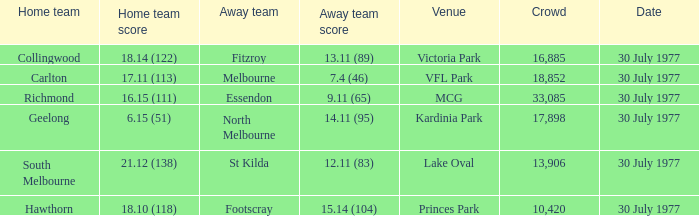What is north melbourne's score as an away side? 14.11 (95). 